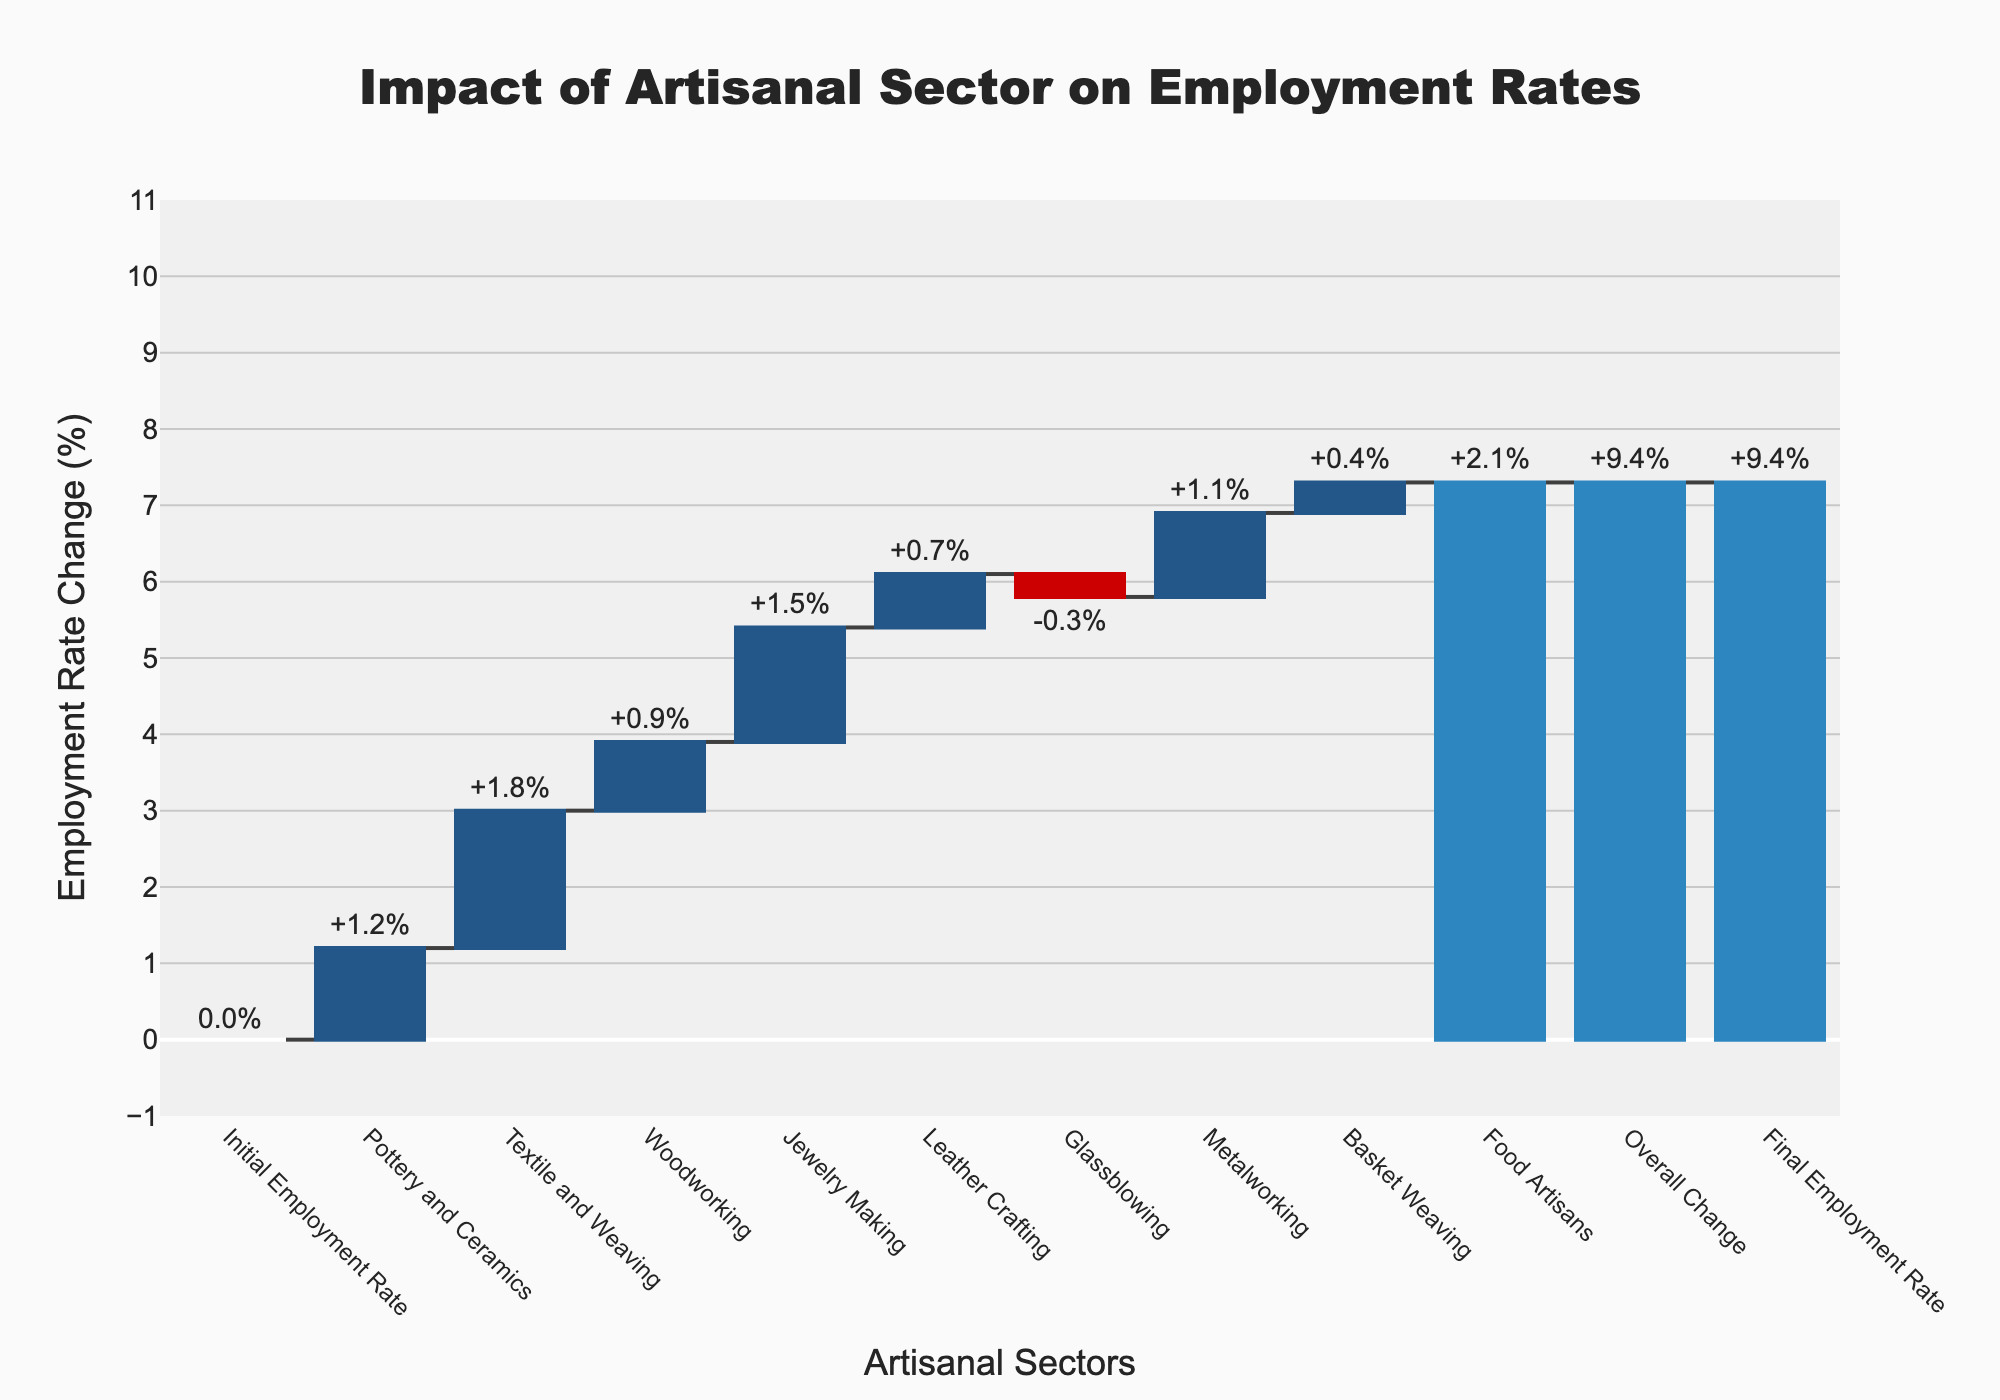What is the title of the chart? The title of the chart is located at the top and is centred. It reads "Impact of Artisanal Sector on Employment Rates".
Answer: Impact of Artisanal Sector on Employment Rates What is the initial employment rate? According to the first bar in the chart, labeled "Initial Employment Rate", the value is 0%.
Answer: 0% How does the change in employment rate from Glassblowing compare to Woodworking? The Glassblowing bar shows a decrease of -0.3% while the Woodworking bar shows an increase of +0.9%.
Answer: Glassblowing is -0.3% and Woodworking is +0.9% Which artisanal sector contributed the most to the employment rate increase? By observing the heights of the bars, "Food Artisans" has the highest increase at +2.1%.
Answer: Food Artisans What is the overall change in employment rate? The "Overall Change" bar shows the total change, which is +9.4%.
Answer: +9.4% What is the final employment rate? The "Final Employment Rate" is shown as the last bar in the chart, and is 9.4%.
Answer: 9.4% Calculate the average employment rate change across all artisanal sectors except the final rate. Sum the employment rate changes: 1.2 + 1.8 + 0.9 + 1.5 + 0.7 - 0.3 + 1.1 + 0.4 + 2.1 = 9.4. There are 9 sectors, so the average is 9.4 / 9 = 1.04%.
Answer: 1.04% How many artisanal sectors have a negative impact on the employment rate? By scanning the chart, only "Glassblowing" shows a negative change with a value of -0.3%.
Answer: 1 What is the difference in employment rate change between Textile and Weaving and Leather Crafting? Textile and Weaving has an increase of +1.8%, and Leather Crafting has an increase of +0.7%. The difference is 1.8% - 0.7% = 1.1%.
Answer: 1.1% Summarize the net change in employment rate contributions by all artisanal sectors. Add all the individual changes together: 1.2 (Pottery and Ceramics) + 1.8 (Textile and Weaving) + 0.9 (Woodworking) + 1.5 (Jewelry Making) + 0.7 (Leather Crafting) - 0.3 (Glassblowing) + 1.1 (Metalworking) + 0.4 (Basket Weaving) + 2.1 (Food Artisans) = 9.4%.
Answer: 9.4% 